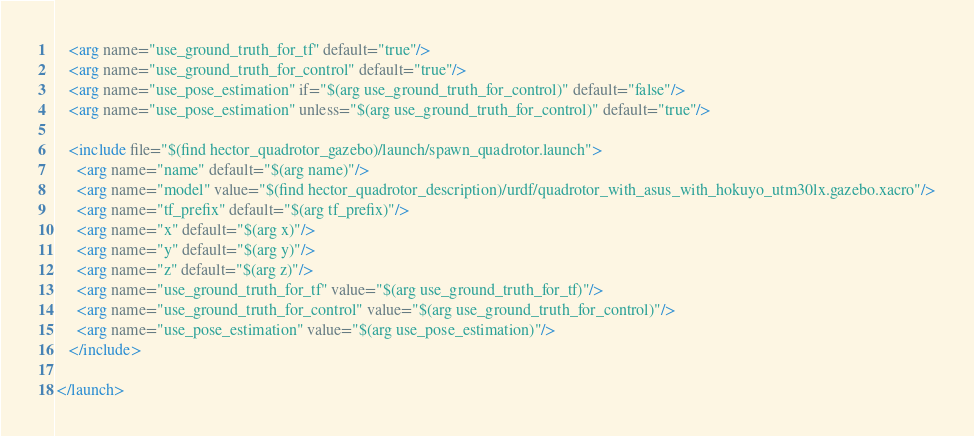Convert code to text. <code><loc_0><loc_0><loc_500><loc_500><_XML_>
   <arg name="use_ground_truth_for_tf" default="true"/>
   <arg name="use_ground_truth_for_control" default="true"/>
   <arg name="use_pose_estimation" if="$(arg use_ground_truth_for_control)" default="false"/>
   <arg name="use_pose_estimation" unless="$(arg use_ground_truth_for_control)" default="true"/>

   <include file="$(find hector_quadrotor_gazebo)/launch/spawn_quadrotor.launch">
     <arg name="name" default="$(arg name)"/>
     <arg name="model" value="$(find hector_quadrotor_description)/urdf/quadrotor_with_asus_with_hokuyo_utm30lx.gazebo.xacro"/>
     <arg name="tf_prefix" default="$(arg tf_prefix)"/>
     <arg name="x" default="$(arg x)"/>
     <arg name="y" default="$(arg y)"/>
     <arg name="z" default="$(arg z)"/>   
     <arg name="use_ground_truth_for_tf" value="$(arg use_ground_truth_for_tf)"/>
     <arg name="use_ground_truth_for_control" value="$(arg use_ground_truth_for_control)"/>
     <arg name="use_pose_estimation" value="$(arg use_pose_estimation)"/>
   </include>

</launch>

</code> 